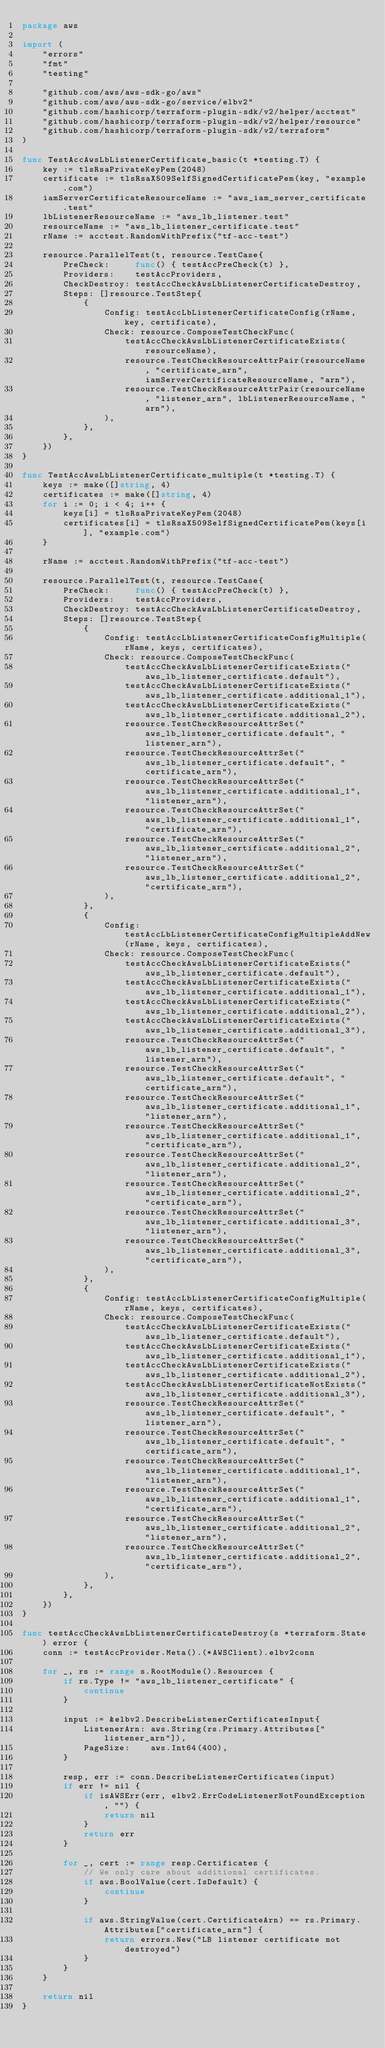<code> <loc_0><loc_0><loc_500><loc_500><_Go_>package aws

import (
	"errors"
	"fmt"
	"testing"

	"github.com/aws/aws-sdk-go/aws"
	"github.com/aws/aws-sdk-go/service/elbv2"
	"github.com/hashicorp/terraform-plugin-sdk/v2/helper/acctest"
	"github.com/hashicorp/terraform-plugin-sdk/v2/helper/resource"
	"github.com/hashicorp/terraform-plugin-sdk/v2/terraform"
)

func TestAccAwsLbListenerCertificate_basic(t *testing.T) {
	key := tlsRsaPrivateKeyPem(2048)
	certificate := tlsRsaX509SelfSignedCertificatePem(key, "example.com")
	iamServerCertificateResourceName := "aws_iam_server_certificate.test"
	lbListenerResourceName := "aws_lb_listener.test"
	resourceName := "aws_lb_listener_certificate.test"
	rName := acctest.RandomWithPrefix("tf-acc-test")

	resource.ParallelTest(t, resource.TestCase{
		PreCheck:     func() { testAccPreCheck(t) },
		Providers:    testAccProviders,
		CheckDestroy: testAccCheckAwsLbListenerCertificateDestroy,
		Steps: []resource.TestStep{
			{
				Config: testAccLbListenerCertificateConfig(rName, key, certificate),
				Check: resource.ComposeTestCheckFunc(
					testAccCheckAwsLbListenerCertificateExists(resourceName),
					resource.TestCheckResourceAttrPair(resourceName, "certificate_arn", iamServerCertificateResourceName, "arn"),
					resource.TestCheckResourceAttrPair(resourceName, "listener_arn", lbListenerResourceName, "arn"),
				),
			},
		},
	})
}

func TestAccAwsLbListenerCertificate_multiple(t *testing.T) {
	keys := make([]string, 4)
	certificates := make([]string, 4)
	for i := 0; i < 4; i++ {
		keys[i] = tlsRsaPrivateKeyPem(2048)
		certificates[i] = tlsRsaX509SelfSignedCertificatePem(keys[i], "example.com")
	}

	rName := acctest.RandomWithPrefix("tf-acc-test")

	resource.ParallelTest(t, resource.TestCase{
		PreCheck:     func() { testAccPreCheck(t) },
		Providers:    testAccProviders,
		CheckDestroy: testAccCheckAwsLbListenerCertificateDestroy,
		Steps: []resource.TestStep{
			{
				Config: testAccLbListenerCertificateConfigMultiple(rName, keys, certificates),
				Check: resource.ComposeTestCheckFunc(
					testAccCheckAwsLbListenerCertificateExists("aws_lb_listener_certificate.default"),
					testAccCheckAwsLbListenerCertificateExists("aws_lb_listener_certificate.additional_1"),
					testAccCheckAwsLbListenerCertificateExists("aws_lb_listener_certificate.additional_2"),
					resource.TestCheckResourceAttrSet("aws_lb_listener_certificate.default", "listener_arn"),
					resource.TestCheckResourceAttrSet("aws_lb_listener_certificate.default", "certificate_arn"),
					resource.TestCheckResourceAttrSet("aws_lb_listener_certificate.additional_1", "listener_arn"),
					resource.TestCheckResourceAttrSet("aws_lb_listener_certificate.additional_1", "certificate_arn"),
					resource.TestCheckResourceAttrSet("aws_lb_listener_certificate.additional_2", "listener_arn"),
					resource.TestCheckResourceAttrSet("aws_lb_listener_certificate.additional_2", "certificate_arn"),
				),
			},
			{
				Config: testAccLbListenerCertificateConfigMultipleAddNew(rName, keys, certificates),
				Check: resource.ComposeTestCheckFunc(
					testAccCheckAwsLbListenerCertificateExists("aws_lb_listener_certificate.default"),
					testAccCheckAwsLbListenerCertificateExists("aws_lb_listener_certificate.additional_1"),
					testAccCheckAwsLbListenerCertificateExists("aws_lb_listener_certificate.additional_2"),
					testAccCheckAwsLbListenerCertificateExists("aws_lb_listener_certificate.additional_3"),
					resource.TestCheckResourceAttrSet("aws_lb_listener_certificate.default", "listener_arn"),
					resource.TestCheckResourceAttrSet("aws_lb_listener_certificate.default", "certificate_arn"),
					resource.TestCheckResourceAttrSet("aws_lb_listener_certificate.additional_1", "listener_arn"),
					resource.TestCheckResourceAttrSet("aws_lb_listener_certificate.additional_1", "certificate_arn"),
					resource.TestCheckResourceAttrSet("aws_lb_listener_certificate.additional_2", "listener_arn"),
					resource.TestCheckResourceAttrSet("aws_lb_listener_certificate.additional_2", "certificate_arn"),
					resource.TestCheckResourceAttrSet("aws_lb_listener_certificate.additional_3", "listener_arn"),
					resource.TestCheckResourceAttrSet("aws_lb_listener_certificate.additional_3", "certificate_arn"),
				),
			},
			{
				Config: testAccLbListenerCertificateConfigMultiple(rName, keys, certificates),
				Check: resource.ComposeTestCheckFunc(
					testAccCheckAwsLbListenerCertificateExists("aws_lb_listener_certificate.default"),
					testAccCheckAwsLbListenerCertificateExists("aws_lb_listener_certificate.additional_1"),
					testAccCheckAwsLbListenerCertificateExists("aws_lb_listener_certificate.additional_2"),
					testAccCheckAwsLbListenerCertificateNotExists("aws_lb_listener_certificate.additional_3"),
					resource.TestCheckResourceAttrSet("aws_lb_listener_certificate.default", "listener_arn"),
					resource.TestCheckResourceAttrSet("aws_lb_listener_certificate.default", "certificate_arn"),
					resource.TestCheckResourceAttrSet("aws_lb_listener_certificate.additional_1", "listener_arn"),
					resource.TestCheckResourceAttrSet("aws_lb_listener_certificate.additional_1", "certificate_arn"),
					resource.TestCheckResourceAttrSet("aws_lb_listener_certificate.additional_2", "listener_arn"),
					resource.TestCheckResourceAttrSet("aws_lb_listener_certificate.additional_2", "certificate_arn"),
				),
			},
		},
	})
}

func testAccCheckAwsLbListenerCertificateDestroy(s *terraform.State) error {
	conn := testAccProvider.Meta().(*AWSClient).elbv2conn

	for _, rs := range s.RootModule().Resources {
		if rs.Type != "aws_lb_listener_certificate" {
			continue
		}

		input := &elbv2.DescribeListenerCertificatesInput{
			ListenerArn: aws.String(rs.Primary.Attributes["listener_arn"]),
			PageSize:    aws.Int64(400),
		}

		resp, err := conn.DescribeListenerCertificates(input)
		if err != nil {
			if isAWSErr(err, elbv2.ErrCodeListenerNotFoundException, "") {
				return nil
			}
			return err
		}

		for _, cert := range resp.Certificates {
			// We only care about additional certificates.
			if aws.BoolValue(cert.IsDefault) {
				continue
			}

			if aws.StringValue(cert.CertificateArn) == rs.Primary.Attributes["certificate_arn"] {
				return errors.New("LB listener certificate not destroyed")
			}
		}
	}

	return nil
}
</code> 